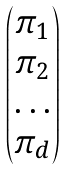<formula> <loc_0><loc_0><loc_500><loc_500>\begin{pmatrix} \pi _ { 1 } \\ \pi _ { 2 } \\ \dots \\ \pi _ { d } \end{pmatrix}</formula> 